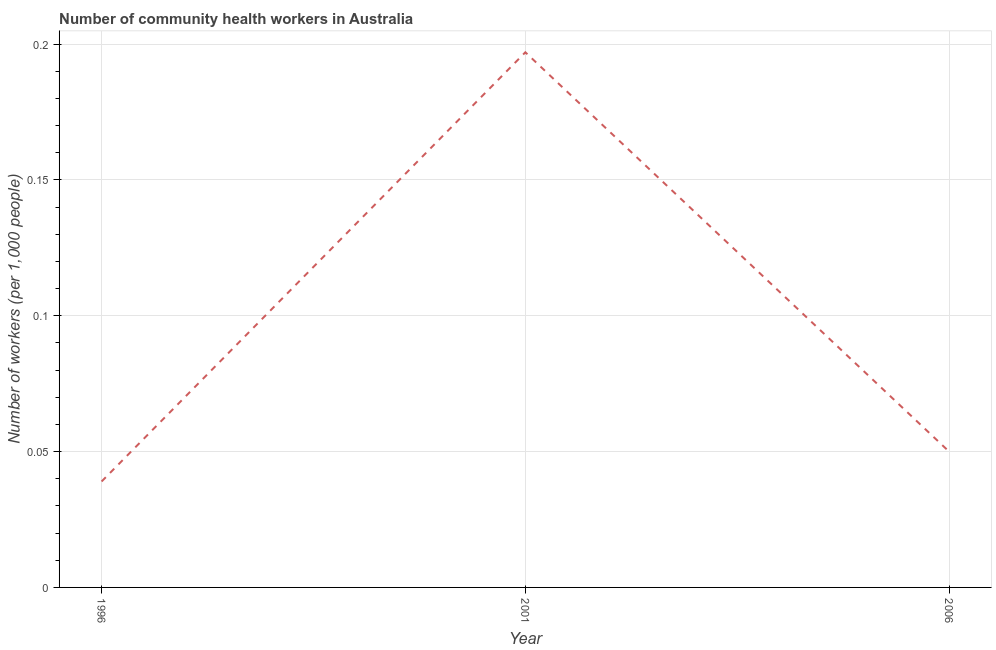What is the number of community health workers in 2001?
Provide a short and direct response. 0.2. Across all years, what is the maximum number of community health workers?
Provide a short and direct response. 0.2. Across all years, what is the minimum number of community health workers?
Provide a short and direct response. 0.04. What is the sum of the number of community health workers?
Offer a terse response. 0.29. What is the difference between the number of community health workers in 1996 and 2006?
Your answer should be compact. -0.01. What is the average number of community health workers per year?
Ensure brevity in your answer.  0.1. What is the median number of community health workers?
Keep it short and to the point. 0.05. What is the ratio of the number of community health workers in 2001 to that in 2006?
Your response must be concise. 3.94. Is the number of community health workers in 2001 less than that in 2006?
Provide a succinct answer. No. What is the difference between the highest and the second highest number of community health workers?
Ensure brevity in your answer.  0.15. What is the difference between the highest and the lowest number of community health workers?
Provide a succinct answer. 0.16. In how many years, is the number of community health workers greater than the average number of community health workers taken over all years?
Provide a succinct answer. 1. Does the number of community health workers monotonically increase over the years?
Provide a succinct answer. No. What is the title of the graph?
Offer a terse response. Number of community health workers in Australia. What is the label or title of the X-axis?
Your answer should be very brief. Year. What is the label or title of the Y-axis?
Your response must be concise. Number of workers (per 1,0 people). What is the Number of workers (per 1,000 people) of 1996?
Provide a short and direct response. 0.04. What is the Number of workers (per 1,000 people) of 2001?
Make the answer very short. 0.2. What is the Number of workers (per 1,000 people) of 2006?
Offer a terse response. 0.05. What is the difference between the Number of workers (per 1,000 people) in 1996 and 2001?
Provide a short and direct response. -0.16. What is the difference between the Number of workers (per 1,000 people) in 1996 and 2006?
Provide a short and direct response. -0.01. What is the difference between the Number of workers (per 1,000 people) in 2001 and 2006?
Your answer should be very brief. 0.15. What is the ratio of the Number of workers (per 1,000 people) in 1996 to that in 2001?
Keep it short and to the point. 0.2. What is the ratio of the Number of workers (per 1,000 people) in 1996 to that in 2006?
Give a very brief answer. 0.78. What is the ratio of the Number of workers (per 1,000 people) in 2001 to that in 2006?
Offer a very short reply. 3.94. 